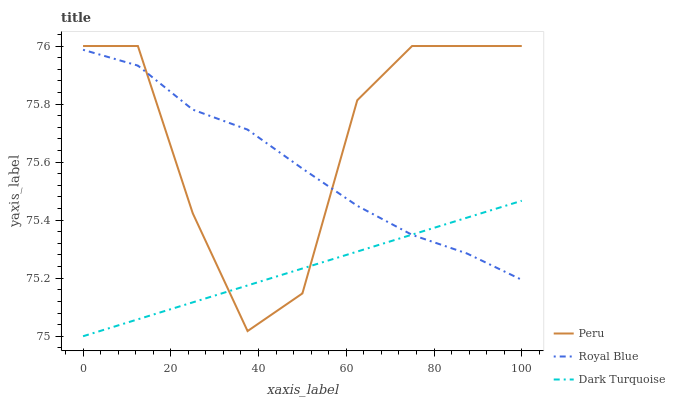Does Peru have the minimum area under the curve?
Answer yes or no. No. Does Dark Turquoise have the maximum area under the curve?
Answer yes or no. No. Is Peru the smoothest?
Answer yes or no. No. Is Dark Turquoise the roughest?
Answer yes or no. No. Does Peru have the lowest value?
Answer yes or no. No. Does Dark Turquoise have the highest value?
Answer yes or no. No. 